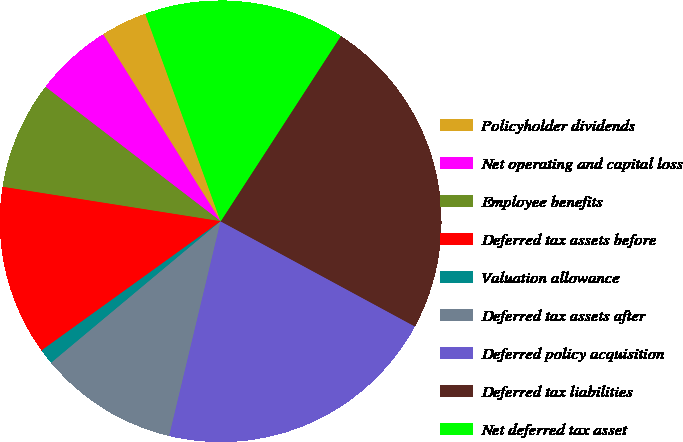Convert chart to OTSL. <chart><loc_0><loc_0><loc_500><loc_500><pie_chart><fcel>Policyholder dividends<fcel>Net operating and capital loss<fcel>Employee benefits<fcel>Deferred tax assets before<fcel>Valuation allowance<fcel>Deferred tax assets after<fcel>Deferred policy acquisition<fcel>Deferred tax liabilities<fcel>Net deferred tax asset<nl><fcel>3.39%<fcel>5.65%<fcel>7.92%<fcel>12.44%<fcel>1.13%<fcel>10.18%<fcel>20.85%<fcel>23.74%<fcel>14.7%<nl></chart> 